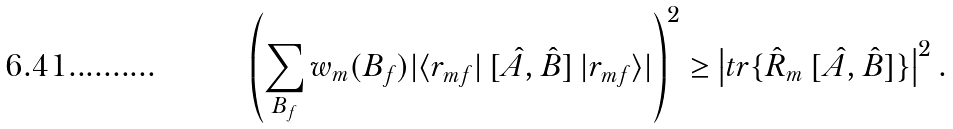Convert formula to latex. <formula><loc_0><loc_0><loc_500><loc_500>\left ( \sum _ { B _ { f } } w _ { m } ( B _ { f } ) | \langle r _ { m f } | \, [ \hat { A } , \hat { B } ] \, | r _ { m f } \rangle | \right ) ^ { 2 } \geq \left | t r \{ \hat { R } _ { m } \, [ \hat { A } , \hat { B } ] \} \right | ^ { 2 } .</formula> 